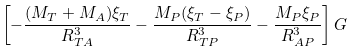<formula> <loc_0><loc_0><loc_500><loc_500>\left [ - \frac { ( M _ { T } + M _ { A } ) \xi _ { T } } { R _ { T A } ^ { 3 } } - \frac { M _ { P } ( \xi _ { T } - \xi _ { P } ) } { R _ { T P } ^ { 3 } } - \frac { M _ { P } \xi _ { P } } { R _ { A P } ^ { 3 } } \right ] G</formula> 